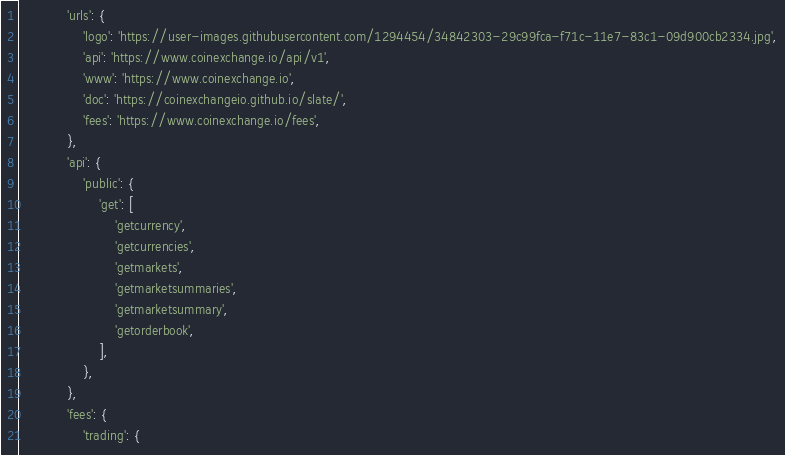<code> <loc_0><loc_0><loc_500><loc_500><_Python_>            'urls': {
                'logo': 'https://user-images.githubusercontent.com/1294454/34842303-29c99fca-f71c-11e7-83c1-09d900cb2334.jpg',
                'api': 'https://www.coinexchange.io/api/v1',
                'www': 'https://www.coinexchange.io',
                'doc': 'https://coinexchangeio.github.io/slate/',
                'fees': 'https://www.coinexchange.io/fees',
            },
            'api': {
                'public': {
                    'get': [
                        'getcurrency',
                        'getcurrencies',
                        'getmarkets',
                        'getmarketsummaries',
                        'getmarketsummary',
                        'getorderbook',
                    ],
                },
            },
            'fees': {
                'trading': {</code> 